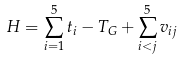Convert formula to latex. <formula><loc_0><loc_0><loc_500><loc_500>H = \sum ^ { 5 } _ { i = 1 } t _ { i } - T _ { G } + \sum ^ { 5 } _ { i < j } v _ { i j }</formula> 